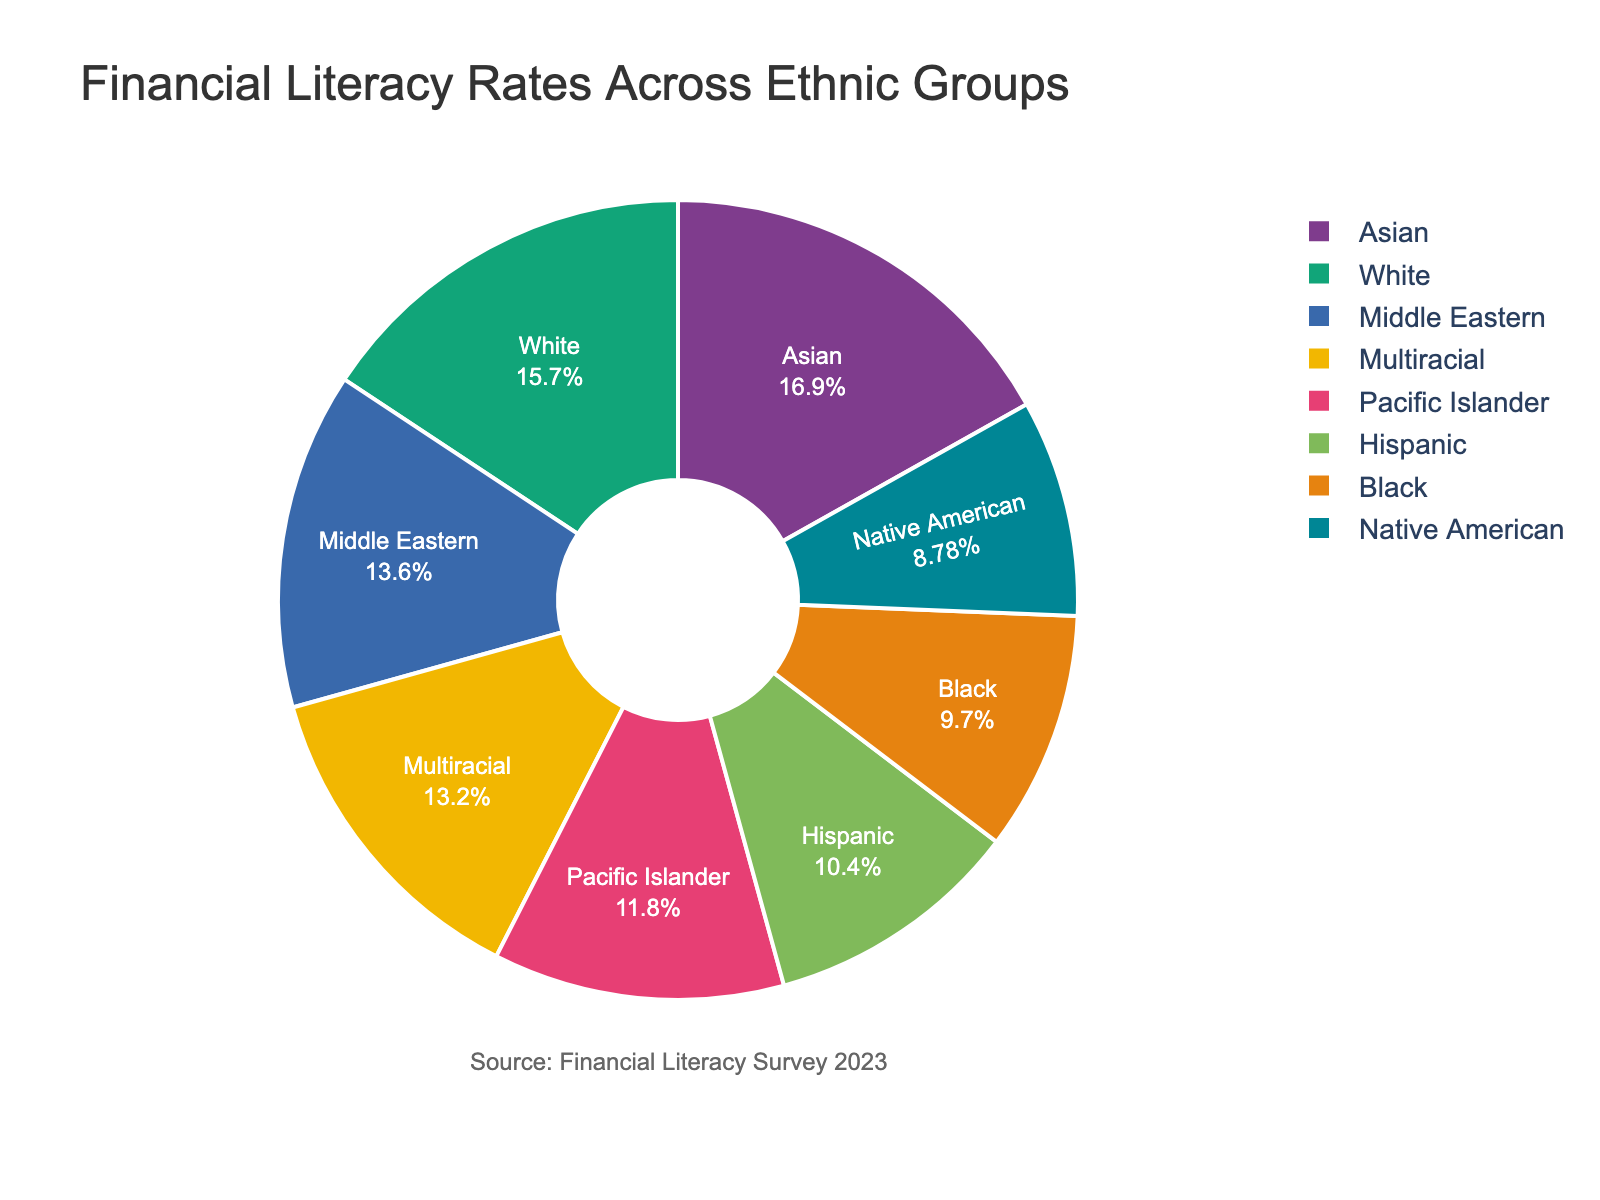What is the financial literacy rate for the group with the highest rate? The pie chart indicates that the group with the highest financial literacy rate is the Asian group. The rate is clearly shown in the pie chart.
Answer: 73% Which ethnic group has a financial literacy rate of 51% and what color is it represented by? By examining the pie chart, we can see that the Pacific Islander group has a financial literacy rate of 51%. The color that represents this group can be identified from the legend in the chart.
Answer: Pacific Islander, [color from the chart] Who has a higher financial literacy rate: Hispanic or Multiracial groups? The Hispanic financial literacy rate is 45%, while the Multiracial group has a rate of 57%. Comparing these values, Multiracial has a higher rate.
Answer: Multiracial What is the average financial literacy rate across all ethnic groups? The sum of financial literacy rates for all groups is (68+42+45+73+38+51+59+57) = 433. The average is the sum divided by the number of groups, so 433/8 = 54.125.
Answer: 54.125 What percentage of the pie chart is represented by the Native American group? The pie chart percentages add up to 100%. The annotation inside the chart for the Native American group should show its specific percentage.
Answer: [Percentage from the chart] Among White and Black groups, who has a larger financial literacy rate, and by how much? By looking at the rates, White group has 68% and Black group has 42%. The difference is calculated as 68% - 42% = 26%.
Answer: White, 26% How does the financial literacy rate of the Middle Eastern group compare to the average rate? The Middle Eastern group has a financial literacy rate of 59%. The average rate, as calculated, is 54.125%. Hence, the Middle Eastern rate is higher than the average by 59% - 54.125% = 4.875%.
Answer: Higher by 4.875% Which groups have financial literacy rates lower than 50%? Referring to the pie chart, we see that Black (42%), Native American (38%), and Hispanic (45%) groups have financial literacy rates below 50%.
Answer: Black, Native American, Hispanic 